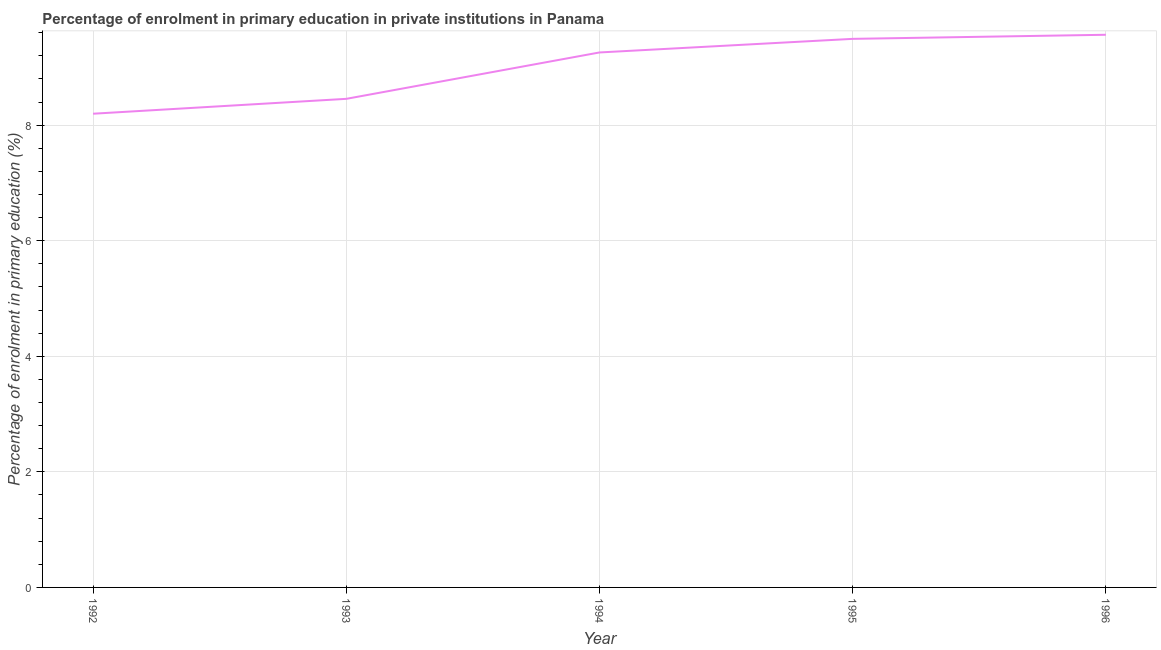What is the enrolment percentage in primary education in 1994?
Provide a short and direct response. 9.26. Across all years, what is the maximum enrolment percentage in primary education?
Give a very brief answer. 9.56. Across all years, what is the minimum enrolment percentage in primary education?
Make the answer very short. 8.2. In which year was the enrolment percentage in primary education minimum?
Your answer should be compact. 1992. What is the sum of the enrolment percentage in primary education?
Ensure brevity in your answer.  44.97. What is the difference between the enrolment percentage in primary education in 1992 and 1993?
Your answer should be compact. -0.26. What is the average enrolment percentage in primary education per year?
Provide a short and direct response. 8.99. What is the median enrolment percentage in primary education?
Your answer should be very brief. 9.26. In how many years, is the enrolment percentage in primary education greater than 4.4 %?
Your answer should be compact. 5. What is the ratio of the enrolment percentage in primary education in 1992 to that in 1994?
Provide a succinct answer. 0.89. Is the enrolment percentage in primary education in 1992 less than that in 1995?
Keep it short and to the point. Yes. What is the difference between the highest and the second highest enrolment percentage in primary education?
Provide a short and direct response. 0.07. What is the difference between the highest and the lowest enrolment percentage in primary education?
Make the answer very short. 1.37. Does the enrolment percentage in primary education monotonically increase over the years?
Give a very brief answer. Yes. How many years are there in the graph?
Make the answer very short. 5. What is the difference between two consecutive major ticks on the Y-axis?
Ensure brevity in your answer.  2. Are the values on the major ticks of Y-axis written in scientific E-notation?
Keep it short and to the point. No. Does the graph contain any zero values?
Make the answer very short. No. What is the title of the graph?
Ensure brevity in your answer.  Percentage of enrolment in primary education in private institutions in Panama. What is the label or title of the Y-axis?
Make the answer very short. Percentage of enrolment in primary education (%). What is the Percentage of enrolment in primary education (%) of 1992?
Ensure brevity in your answer.  8.2. What is the Percentage of enrolment in primary education (%) of 1993?
Your answer should be compact. 8.45. What is the Percentage of enrolment in primary education (%) in 1994?
Provide a succinct answer. 9.26. What is the Percentage of enrolment in primary education (%) in 1995?
Ensure brevity in your answer.  9.49. What is the Percentage of enrolment in primary education (%) in 1996?
Offer a very short reply. 9.56. What is the difference between the Percentage of enrolment in primary education (%) in 1992 and 1993?
Offer a very short reply. -0.26. What is the difference between the Percentage of enrolment in primary education (%) in 1992 and 1994?
Your answer should be compact. -1.06. What is the difference between the Percentage of enrolment in primary education (%) in 1992 and 1995?
Provide a short and direct response. -1.3. What is the difference between the Percentage of enrolment in primary education (%) in 1992 and 1996?
Ensure brevity in your answer.  -1.37. What is the difference between the Percentage of enrolment in primary education (%) in 1993 and 1994?
Offer a very short reply. -0.8. What is the difference between the Percentage of enrolment in primary education (%) in 1993 and 1995?
Your answer should be compact. -1.04. What is the difference between the Percentage of enrolment in primary education (%) in 1993 and 1996?
Provide a succinct answer. -1.11. What is the difference between the Percentage of enrolment in primary education (%) in 1994 and 1995?
Your response must be concise. -0.24. What is the difference between the Percentage of enrolment in primary education (%) in 1994 and 1996?
Keep it short and to the point. -0.31. What is the difference between the Percentage of enrolment in primary education (%) in 1995 and 1996?
Make the answer very short. -0.07. What is the ratio of the Percentage of enrolment in primary education (%) in 1992 to that in 1993?
Keep it short and to the point. 0.97. What is the ratio of the Percentage of enrolment in primary education (%) in 1992 to that in 1994?
Offer a very short reply. 0.89. What is the ratio of the Percentage of enrolment in primary education (%) in 1992 to that in 1995?
Your answer should be compact. 0.86. What is the ratio of the Percentage of enrolment in primary education (%) in 1992 to that in 1996?
Give a very brief answer. 0.86. What is the ratio of the Percentage of enrolment in primary education (%) in 1993 to that in 1994?
Give a very brief answer. 0.91. What is the ratio of the Percentage of enrolment in primary education (%) in 1993 to that in 1995?
Offer a terse response. 0.89. What is the ratio of the Percentage of enrolment in primary education (%) in 1993 to that in 1996?
Your answer should be very brief. 0.88. What is the ratio of the Percentage of enrolment in primary education (%) in 1994 to that in 1996?
Your answer should be compact. 0.97. 